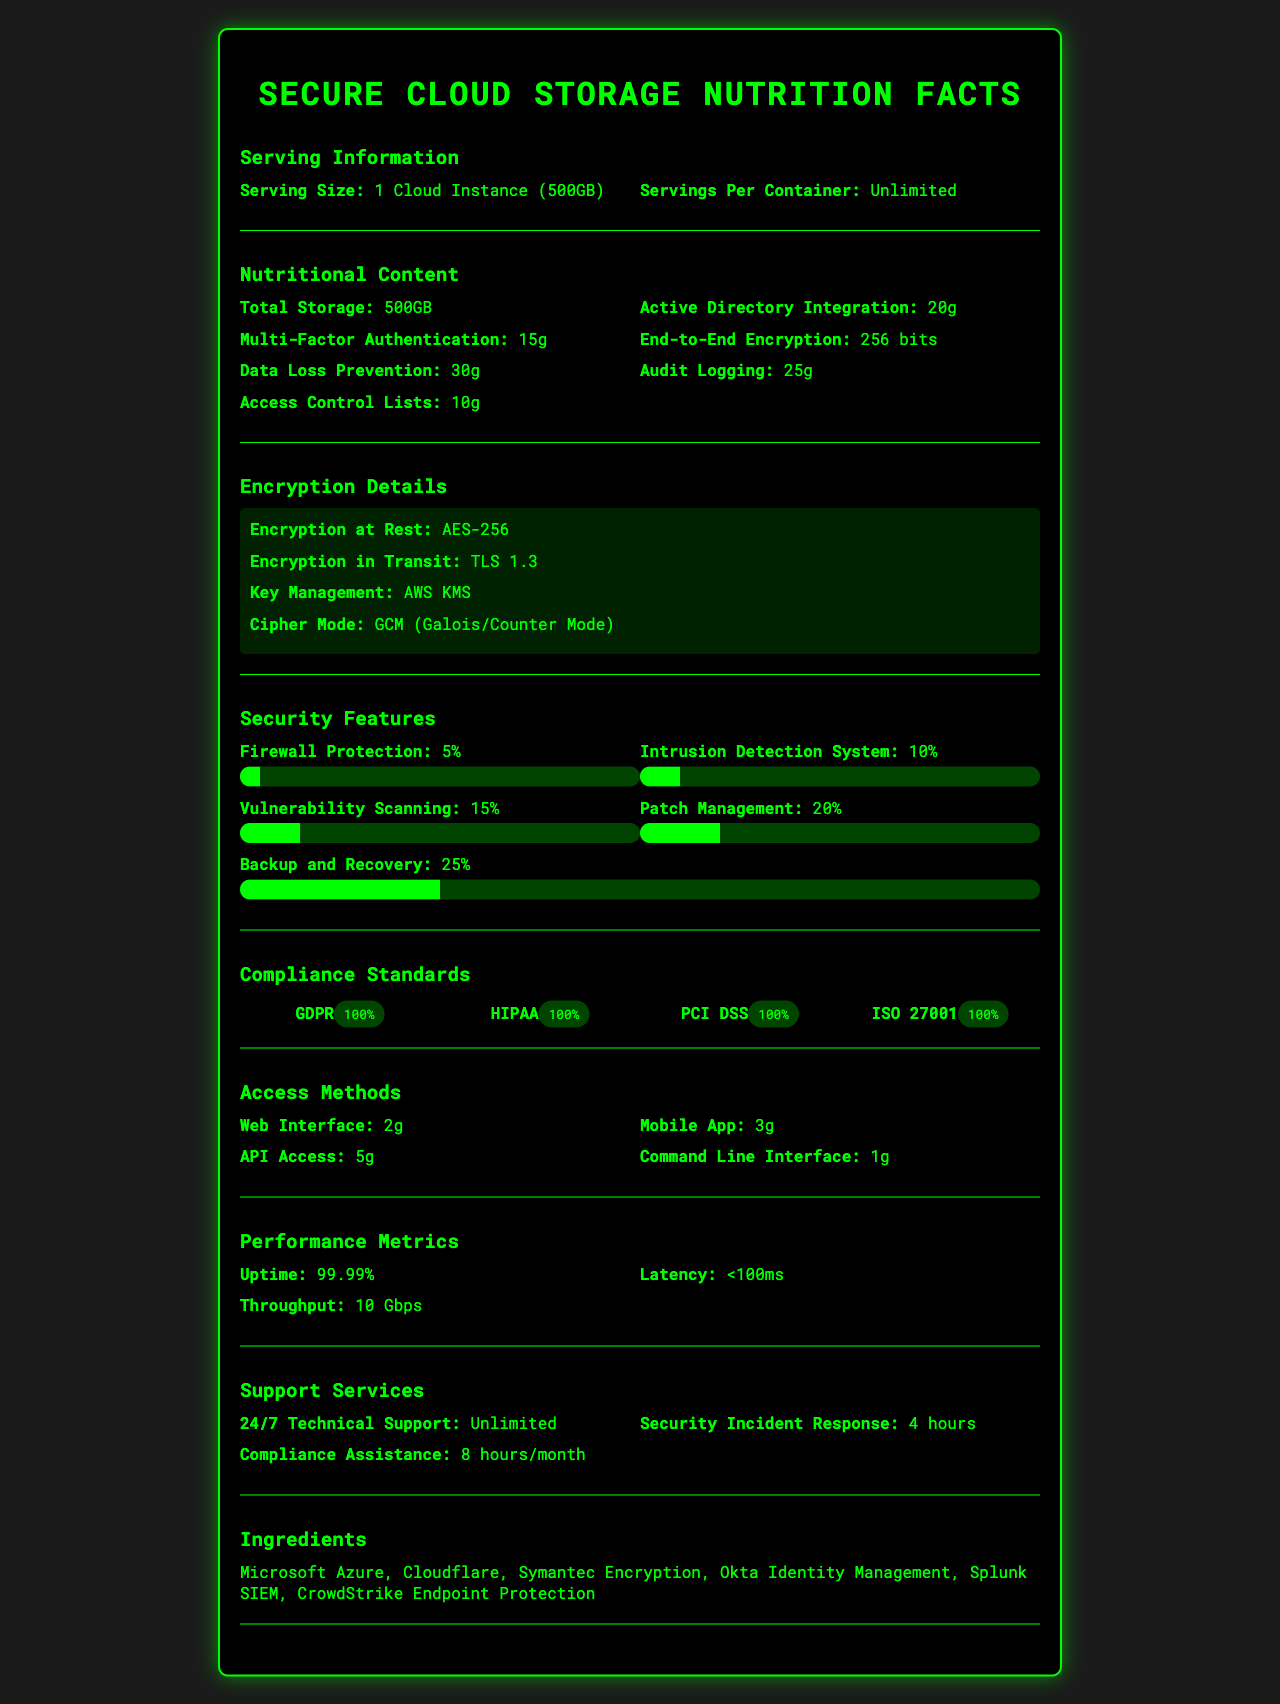what is the serving size? The serving size is listed at the beginning of the document under "Serving Information."
Answer: 1 Cloud Instance (500GB) how much "Multi-Factor Authentication" is present in the secure cloud storage solution? The amount of "Multi-Factor Authentication" is listed under the "Nutritional Content" section.
Answer: 15g what type of encryption is used at rest? This information is under the "Encryption Details" section.
Answer: AES-256 what is the uptime performance metric? The uptime performance metric is listed under the "Performance Metrics" section.
Answer: 99.99% what security feature has the highest percentage in the security meter? Backup and Recovery has the highest percentage, which is 25%, as observed from the security meter visualization under the "Security Features" section.
Answer: Backup and Recovery which compliance standards does the secure cloud storage solution meet? A. GDPR B. HIPAA C. PCI DSS D. ISO 27001 E. All of the above The document shows that the solution meets all listed compliance standards (GDPR, HIPAA, PCI DSS, and ISO 27001) with 100% compliance under the "Compliance Standards" section.
Answer: E. All of the above how many access methods are provided for the secure cloud storage solution? A. 2 B. 3 C. 4 D. 5 The document lists four access methods under the "Access Methods" section: Web Interface, Mobile App, API Access, Command Line Interface.
Answer: C. 4 are the data loss prevention measures stronger than the audit logging capabilities? The nutritional content section lists 30g for Data Loss Prevention and 25g for Audit Logging, indicating that Data Loss Prevention measures are stronger.
Answer: Yes does the storage solution include 24/7 technical support? The "Support Services" section mentions "24/7 Technical Support" indicating continuous availability.
Answer: Yes what are the main ideas conveyed by the document? This summary captures the various sections and key points presented in the document, giving an overall understanding of the secure cloud storage solution.
Answer: The document provides a comprehensive overview of a secure cloud storage solution, detailing its serving size, nutritional content, encryption details, security features, compliance standards, access methods, performance metrics, support services, and the technologies it incorporates. which encryption algorithm is used for encryption in transit? The encryption in transit uses TLS 1.3 as listed in the "Encryption Details" section.
Answer: TLS 1.3 what is the latency performance metric for the cloud storage solution? The latency performance metric is provided under the "Performance Metrics" section with a value of less than 100ms.
Answer: <100ms what is the total storage available in one cloud instance? The total storage listed under the "Nutritional Content" section is 500GB.
Answer: 500GB do you need more information to understand how frequently patches are applied in the patch management process? The document lists "Patch Management" as a security feature with a 20% meter but does not provide specific details on the frequency of patch application.
Answer: Cannot be determined 